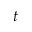<formula> <loc_0><loc_0><loc_500><loc_500>t</formula> 